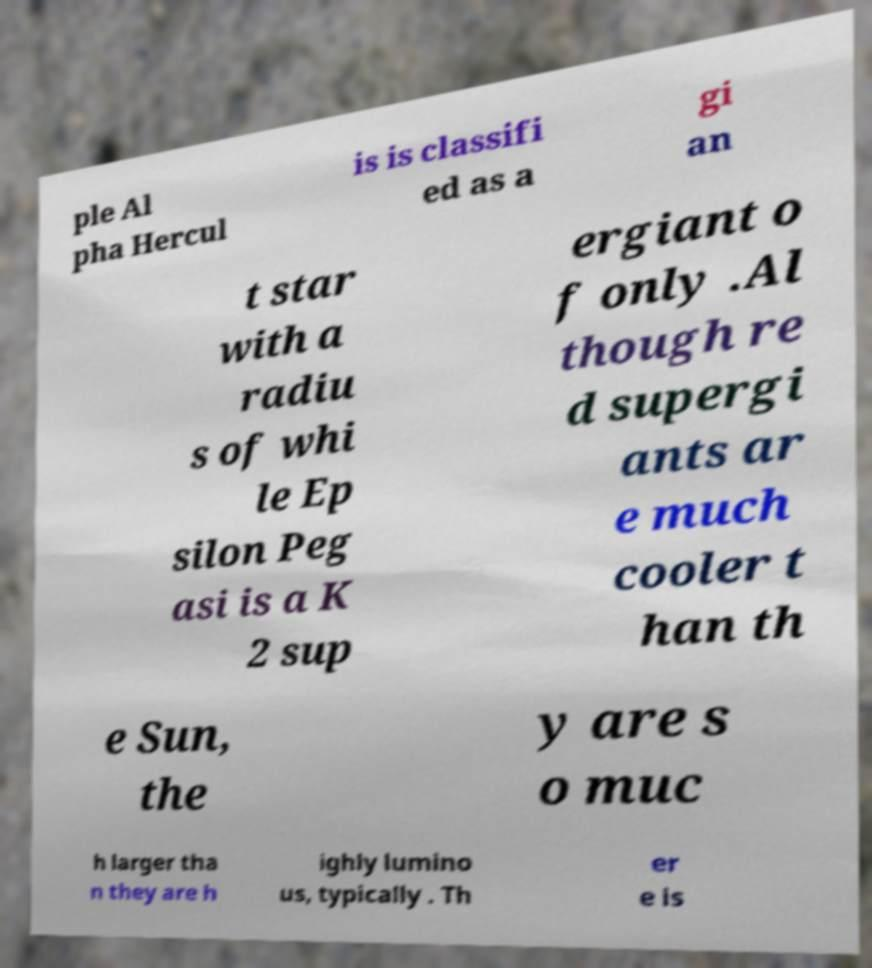I need the written content from this picture converted into text. Can you do that? ple Al pha Hercul is is classifi ed as a gi an t star with a radiu s of whi le Ep silon Peg asi is a K 2 sup ergiant o f only .Al though re d supergi ants ar e much cooler t han th e Sun, the y are s o muc h larger tha n they are h ighly lumino us, typically . Th er e is 